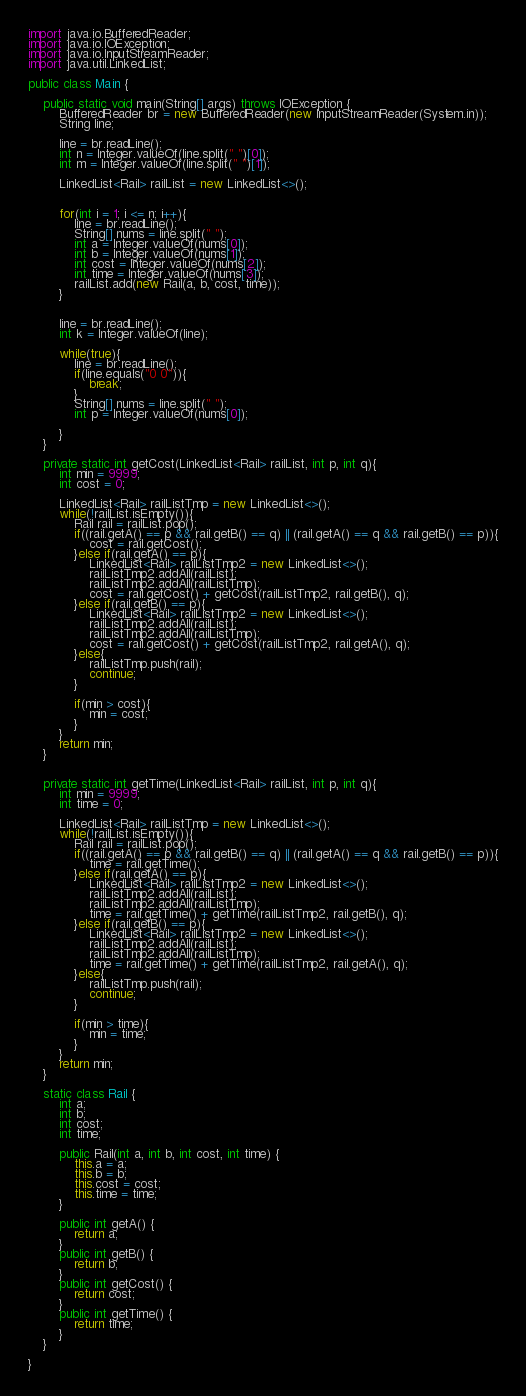<code> <loc_0><loc_0><loc_500><loc_500><_Java_>

import java.io.BufferedReader;
import java.io.IOException;
import java.io.InputStreamReader;
import java.util.LinkedList;

public class Main {

	public static void main(String[] args) throws IOException {
		BufferedReader br = new BufferedReader(new InputStreamReader(System.in));
		String line;

		line = br.readLine();
		int n = Integer.valueOf(line.split(" ")[0]);
		int m = Integer.valueOf(line.split(" ")[1]);
		
		LinkedList<Rail> railList = new LinkedList<>();

		
		for(int i = 1; i <= n; i++){
			line = br.readLine();
			String[] nums = line.split(" ");
			int a = Integer.valueOf(nums[0]);
			int b = Integer.valueOf(nums[1]);
			int cost = Integer.valueOf(nums[2]);
			int time = Integer.valueOf(nums[3]);
			railList.add(new Rail(a, b, cost, time));
		}


		line = br.readLine();
		int k = Integer.valueOf(line);
		
		while(true){
			line = br.readLine();
			if(line.equals("0 0")){
				break;
			}
			String[] nums = line.split(" ");
			int p = Integer.valueOf(nums[0]);

		}
	}
	
	private static int getCost(LinkedList<Rail> railList, int p, int q){
		int min = 9999;
		int cost = 0;
		
		LinkedList<Rail> railListTmp = new LinkedList<>();
		while(!railList.isEmpty()){
			Rail rail = railList.pop();
			if((rail.getA() == p && rail.getB() == q) || (rail.getA() == q && rail.getB() == p)){
				cost = rail.getCost();
			}else if(rail.getA() == p){
				LinkedList<Rail> railListTmp2 = new LinkedList<>();
				railListTmp2.addAll(railList);
				railListTmp2.addAll(railListTmp);
				cost = rail.getCost() + getCost(railListTmp2, rail.getB(), q);
			}else if(rail.getB() == p){
				LinkedList<Rail> railListTmp2 = new LinkedList<>();
				railListTmp2.addAll(railList);
				railListTmp2.addAll(railListTmp);
				cost = rail.getCost() + getCost(railListTmp2, rail.getA(), q);
			}else{
				railListTmp.push(rail);
				continue;
			}
			
			if(min > cost){
				min = cost;
			}
		}
		return min;
	}

	
	private static int getTime(LinkedList<Rail> railList, int p, int q){
		int min = 9999;
		int time = 0;
		
		LinkedList<Rail> railListTmp = new LinkedList<>();
		while(!railList.isEmpty()){
			Rail rail = railList.pop();
			if((rail.getA() == p && rail.getB() == q) || (rail.getA() == q && rail.getB() == p)){
				time = rail.getTime();
			}else if(rail.getA() == p){
				LinkedList<Rail> railListTmp2 = new LinkedList<>();
				railListTmp2.addAll(railList);
				railListTmp2.addAll(railListTmp);
				time = rail.getTime() + getTime(railListTmp2, rail.getB(), q);
			}else if(rail.getB() == p){
				LinkedList<Rail> railListTmp2 = new LinkedList<>();
				railListTmp2.addAll(railList);
				railListTmp2.addAll(railListTmp);
				time = rail.getTime() + getTime(railListTmp2, rail.getA(), q);
			}else{
				railListTmp.push(rail);
				continue;
			}
			
			if(min > time){
				min = time;
			}
		}
		return min;
	}
	
	static class Rail {
		int a;
		int b;
		int cost;
		int time;
		
		public Rail(int a, int b, int cost, int time) {
			this.a = a;
			this.b = b;
			this.cost = cost;
			this.time = time;
		}
		
		public int getA() {
			return a;
		}
		public int getB() {
			return b;
		}
		public int getCost() {
			return cost;
		}
		public int getTime() {
			return time;
		}
	}

}</code> 